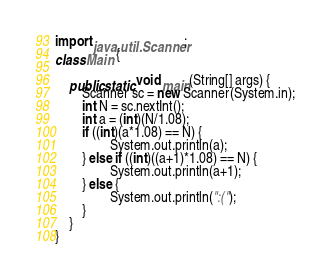Convert code to text. <code><loc_0><loc_0><loc_500><loc_500><_Java_>import java.util.Scanner;
class Main {
	
    public static void main(String[] args) {
        Scanner sc = new Scanner(System.in);
        int N = sc.nextInt();
        int a = (int)(N/1.08);
        if ((int)(a*1.08) == N) {
        		System.out.println(a);
        } else if ((int)((a+1)*1.08) == N) {
        		System.out.println(a+1);
        } else {
        		System.out.println(":(");
        }
    }
} </code> 